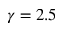<formula> <loc_0><loc_0><loc_500><loc_500>\gamma = 2 . 5</formula> 